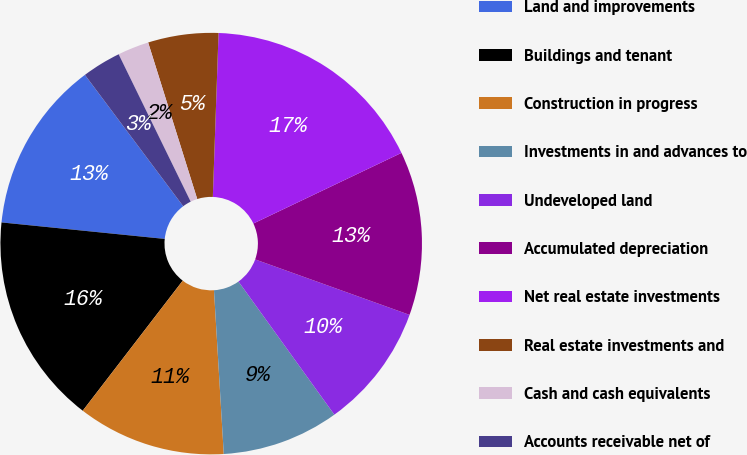Convert chart. <chart><loc_0><loc_0><loc_500><loc_500><pie_chart><fcel>Land and improvements<fcel>Buildings and tenant<fcel>Construction in progress<fcel>Investments in and advances to<fcel>Undeveloped land<fcel>Accumulated depreciation<fcel>Net real estate investments<fcel>Real estate investments and<fcel>Cash and cash equivalents<fcel>Accounts receivable net of<nl><fcel>13.17%<fcel>16.17%<fcel>11.38%<fcel>8.98%<fcel>9.58%<fcel>12.57%<fcel>17.36%<fcel>5.39%<fcel>2.4%<fcel>2.99%<nl></chart> 